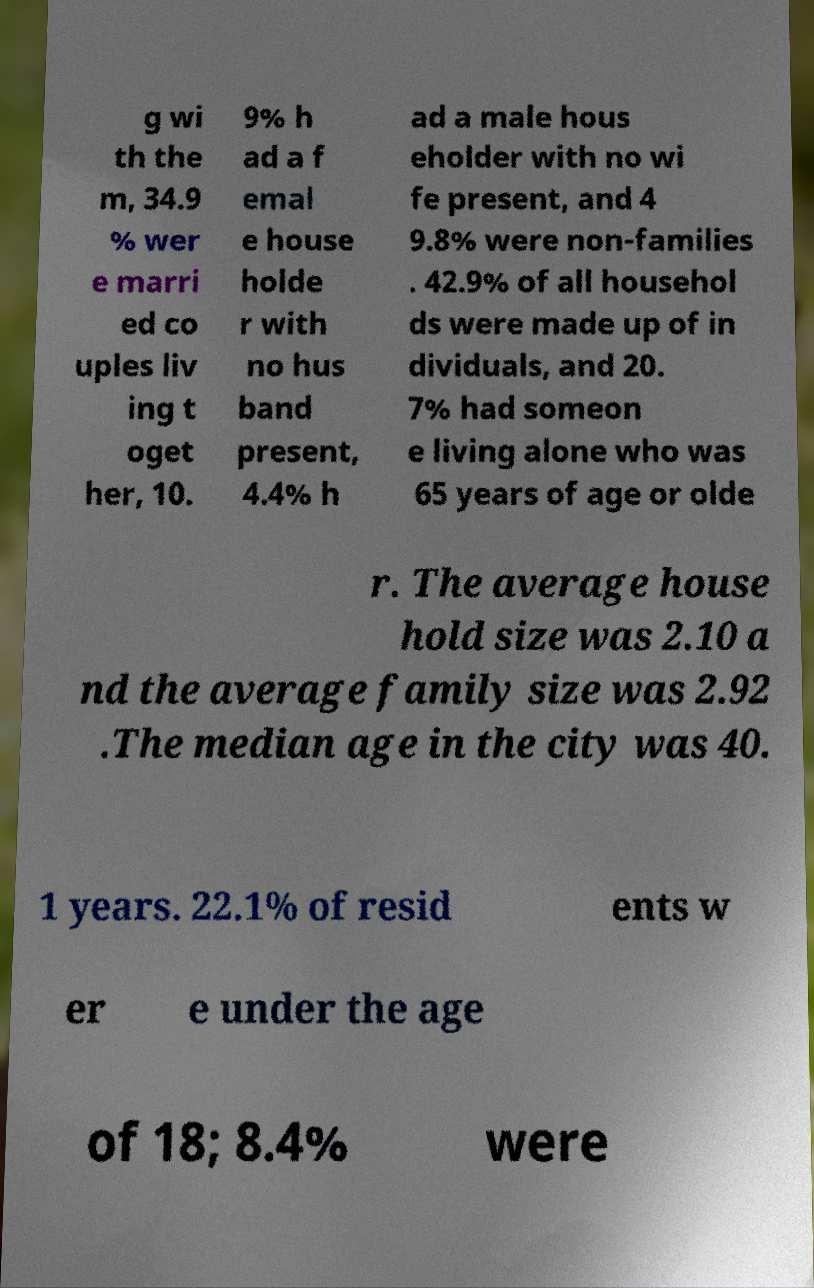Please identify and transcribe the text found in this image. g wi th the m, 34.9 % wer e marri ed co uples liv ing t oget her, 10. 9% h ad a f emal e house holde r with no hus band present, 4.4% h ad a male hous eholder with no wi fe present, and 4 9.8% were non-families . 42.9% of all househol ds were made up of in dividuals, and 20. 7% had someon e living alone who was 65 years of age or olde r. The average house hold size was 2.10 a nd the average family size was 2.92 .The median age in the city was 40. 1 years. 22.1% of resid ents w er e under the age of 18; 8.4% were 